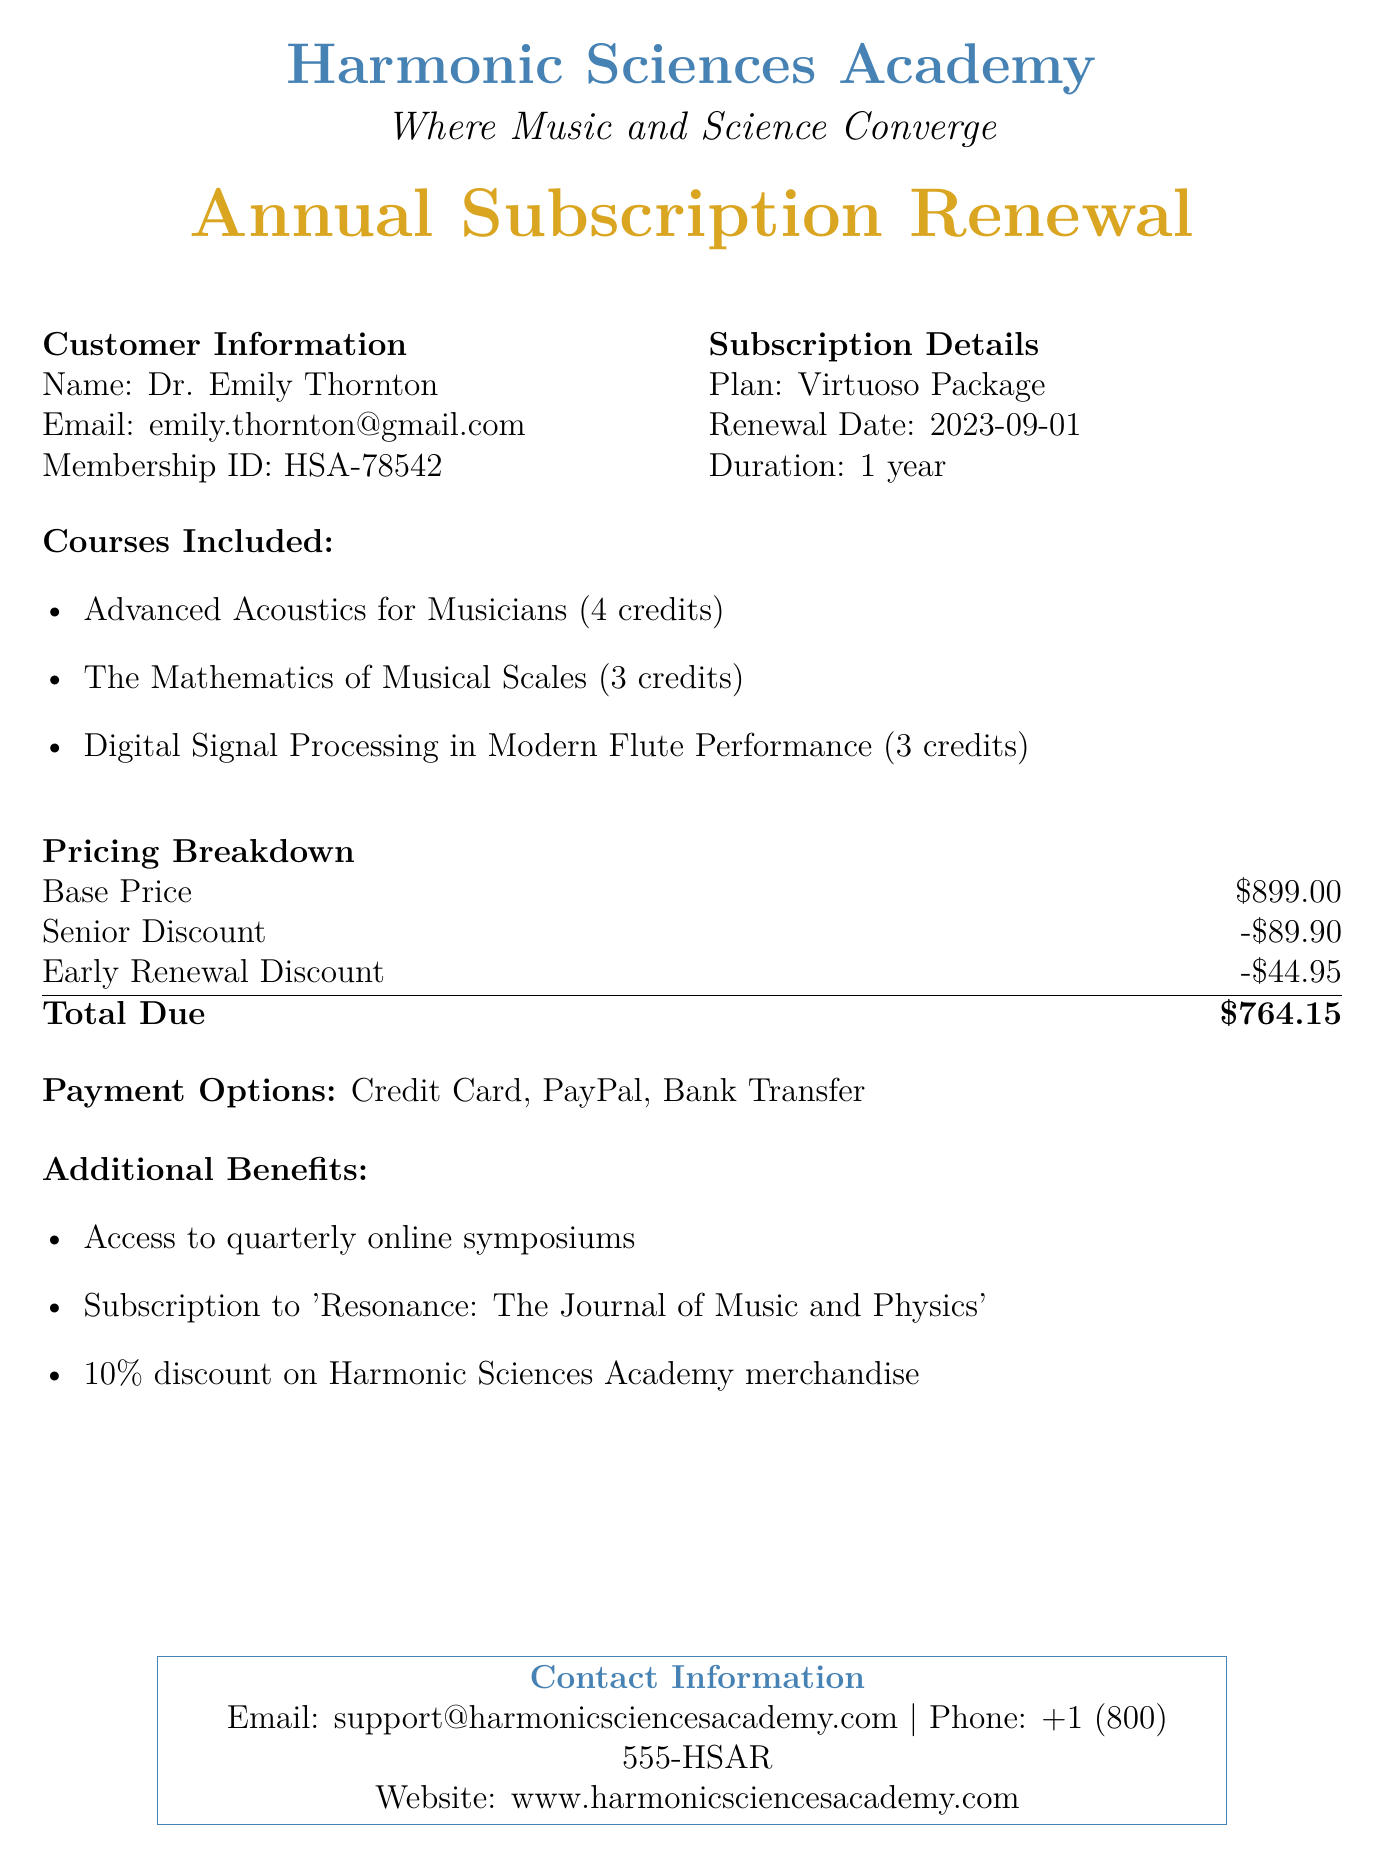What is the name of the customer? The customer's name is listed in the customer information section of the document.
Answer: Dr. Emily Thornton What is the total due for the subscription? The total due is calculated based on the pricing breakdown provided in the document.
Answer: $764.15 What is the renewal date? The renewal date is specified in the subscription details section of the document.
Answer: 2023-09-01 How many credits is "Digital Signal Processing in Modern Flute Performance"? The number of credits for this course can be found under the courses included section.
Answer: 3 credits What is the discount for seniors? The senior discount amount is mentioned in the pricing breakdown.
Answer: -$89.90 What additional benefit includes access to a journal? This aspect of the document points to one of the listed additional benefits.
Answer: Subscription to 'Resonance: The Journal of Music and Physics' What is the plan type? The plan type is mentioned in the subscription details section of the document.
Answer: Virtuoso Package What is the early renewal discount? The early renewal discount amount is stated in the pricing breakdown of the document.
Answer: -$44.95 What payment options are available? The document lists the various payment options available for the subscription.
Answer: Credit Card, PayPal, Bank Transfer 